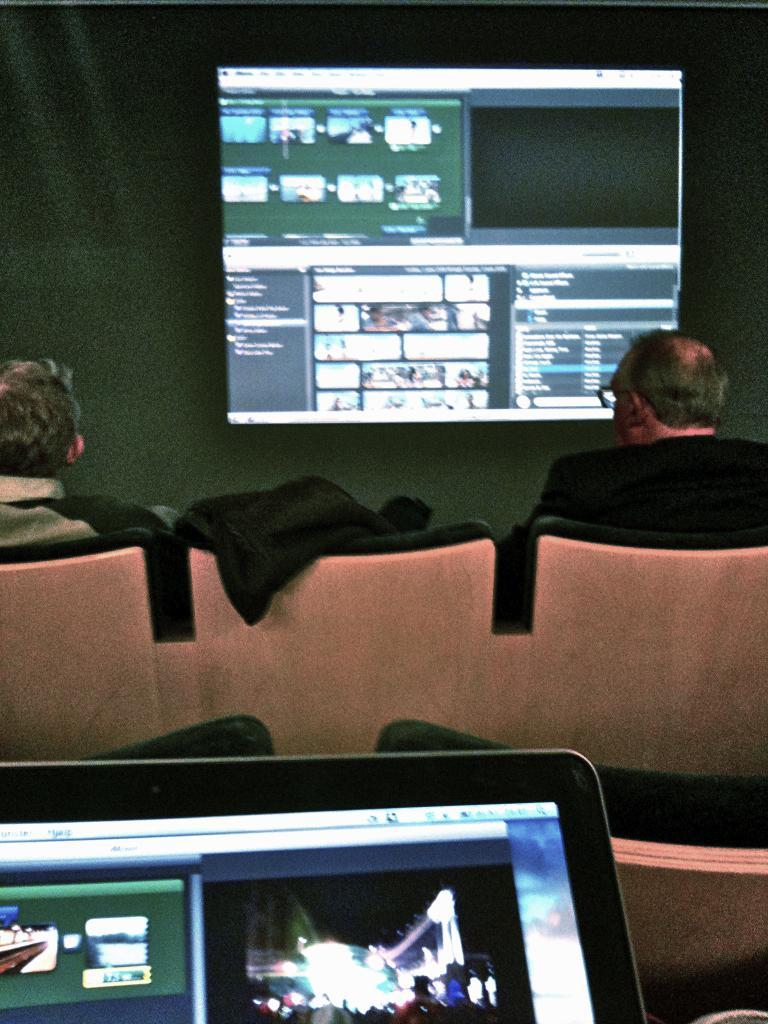What electronic device is present in the image? There is a laptop in the image. How many people are sitting in the image? There are two men sitting on chairs in the image. What can be seen behind the men in the image? There is a screen visible in the background of the image. What type of food is being prepared on the plough in the image? There is no plough or food preparation visible in the image. 